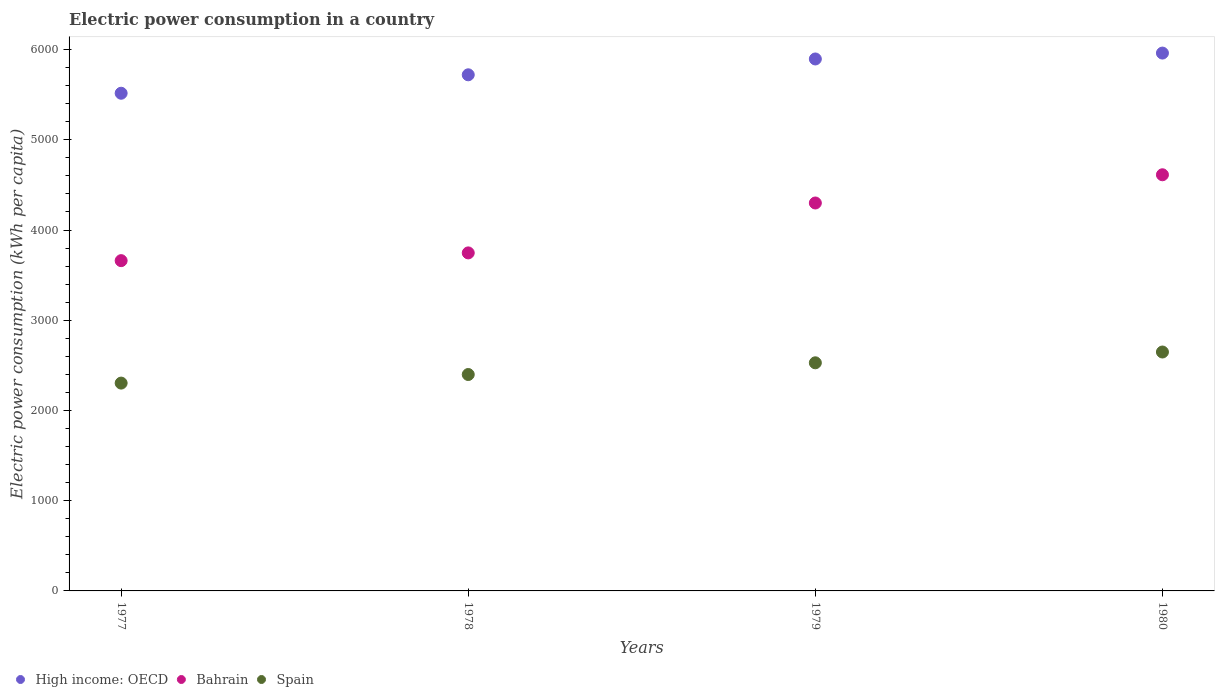Is the number of dotlines equal to the number of legend labels?
Offer a very short reply. Yes. What is the electric power consumption in in Spain in 1977?
Your answer should be very brief. 2303.41. Across all years, what is the maximum electric power consumption in in Spain?
Make the answer very short. 2647.9. Across all years, what is the minimum electric power consumption in in High income: OECD?
Provide a short and direct response. 5515.92. In which year was the electric power consumption in in Spain maximum?
Your answer should be compact. 1980. What is the total electric power consumption in in Spain in the graph?
Give a very brief answer. 9878.13. What is the difference between the electric power consumption in in High income: OECD in 1978 and that in 1980?
Offer a terse response. -240.79. What is the difference between the electric power consumption in in High income: OECD in 1978 and the electric power consumption in in Bahrain in 1977?
Keep it short and to the point. 2059.83. What is the average electric power consumption in in Spain per year?
Your answer should be very brief. 2469.53. In the year 1978, what is the difference between the electric power consumption in in High income: OECD and electric power consumption in in Spain?
Keep it short and to the point. 3321.81. In how many years, is the electric power consumption in in High income: OECD greater than 2400 kWh per capita?
Give a very brief answer. 4. What is the ratio of the electric power consumption in in High income: OECD in 1977 to that in 1979?
Your answer should be compact. 0.94. Is the electric power consumption in in Spain in 1977 less than that in 1978?
Offer a terse response. Yes. Is the difference between the electric power consumption in in High income: OECD in 1977 and 1980 greater than the difference between the electric power consumption in in Spain in 1977 and 1980?
Ensure brevity in your answer.  No. What is the difference between the highest and the second highest electric power consumption in in Bahrain?
Provide a short and direct response. 312.85. What is the difference between the highest and the lowest electric power consumption in in Spain?
Ensure brevity in your answer.  344.5. In how many years, is the electric power consumption in in Spain greater than the average electric power consumption in in Spain taken over all years?
Offer a terse response. 2. Does the electric power consumption in in Bahrain monotonically increase over the years?
Offer a terse response. Yes. How many dotlines are there?
Your answer should be very brief. 3. Are the values on the major ticks of Y-axis written in scientific E-notation?
Provide a succinct answer. No. Does the graph contain any zero values?
Ensure brevity in your answer.  No. Where does the legend appear in the graph?
Provide a succinct answer. Bottom left. How many legend labels are there?
Offer a terse response. 3. How are the legend labels stacked?
Keep it short and to the point. Horizontal. What is the title of the graph?
Provide a succinct answer. Electric power consumption in a country. Does "Equatorial Guinea" appear as one of the legend labels in the graph?
Make the answer very short. No. What is the label or title of the X-axis?
Make the answer very short. Years. What is the label or title of the Y-axis?
Your answer should be very brief. Electric power consumption (kWh per capita). What is the Electric power consumption (kWh per capita) of High income: OECD in 1977?
Give a very brief answer. 5515.92. What is the Electric power consumption (kWh per capita) of Bahrain in 1977?
Make the answer very short. 3660.52. What is the Electric power consumption (kWh per capita) of Spain in 1977?
Give a very brief answer. 2303.41. What is the Electric power consumption (kWh per capita) of High income: OECD in 1978?
Ensure brevity in your answer.  5720.35. What is the Electric power consumption (kWh per capita) of Bahrain in 1978?
Your answer should be very brief. 3746.4. What is the Electric power consumption (kWh per capita) in Spain in 1978?
Give a very brief answer. 2398.54. What is the Electric power consumption (kWh per capita) in High income: OECD in 1979?
Make the answer very short. 5895.81. What is the Electric power consumption (kWh per capita) in Bahrain in 1979?
Make the answer very short. 4299.52. What is the Electric power consumption (kWh per capita) of Spain in 1979?
Offer a terse response. 2528.28. What is the Electric power consumption (kWh per capita) in High income: OECD in 1980?
Make the answer very short. 5961.14. What is the Electric power consumption (kWh per capita) in Bahrain in 1980?
Offer a very short reply. 4612.37. What is the Electric power consumption (kWh per capita) in Spain in 1980?
Provide a succinct answer. 2647.9. Across all years, what is the maximum Electric power consumption (kWh per capita) of High income: OECD?
Provide a short and direct response. 5961.14. Across all years, what is the maximum Electric power consumption (kWh per capita) in Bahrain?
Keep it short and to the point. 4612.37. Across all years, what is the maximum Electric power consumption (kWh per capita) of Spain?
Make the answer very short. 2647.9. Across all years, what is the minimum Electric power consumption (kWh per capita) in High income: OECD?
Ensure brevity in your answer.  5515.92. Across all years, what is the minimum Electric power consumption (kWh per capita) in Bahrain?
Ensure brevity in your answer.  3660.52. Across all years, what is the minimum Electric power consumption (kWh per capita) in Spain?
Make the answer very short. 2303.41. What is the total Electric power consumption (kWh per capita) of High income: OECD in the graph?
Provide a short and direct response. 2.31e+04. What is the total Electric power consumption (kWh per capita) of Bahrain in the graph?
Offer a very short reply. 1.63e+04. What is the total Electric power consumption (kWh per capita) in Spain in the graph?
Provide a succinct answer. 9878.13. What is the difference between the Electric power consumption (kWh per capita) of High income: OECD in 1977 and that in 1978?
Your answer should be very brief. -204.43. What is the difference between the Electric power consumption (kWh per capita) in Bahrain in 1977 and that in 1978?
Give a very brief answer. -85.88. What is the difference between the Electric power consumption (kWh per capita) of Spain in 1977 and that in 1978?
Offer a terse response. -95.13. What is the difference between the Electric power consumption (kWh per capita) of High income: OECD in 1977 and that in 1979?
Give a very brief answer. -379.89. What is the difference between the Electric power consumption (kWh per capita) in Bahrain in 1977 and that in 1979?
Provide a succinct answer. -639. What is the difference between the Electric power consumption (kWh per capita) of Spain in 1977 and that in 1979?
Offer a terse response. -224.88. What is the difference between the Electric power consumption (kWh per capita) of High income: OECD in 1977 and that in 1980?
Your response must be concise. -445.22. What is the difference between the Electric power consumption (kWh per capita) of Bahrain in 1977 and that in 1980?
Your answer should be very brief. -951.85. What is the difference between the Electric power consumption (kWh per capita) in Spain in 1977 and that in 1980?
Provide a succinct answer. -344.5. What is the difference between the Electric power consumption (kWh per capita) in High income: OECD in 1978 and that in 1979?
Your answer should be very brief. -175.47. What is the difference between the Electric power consumption (kWh per capita) in Bahrain in 1978 and that in 1979?
Your answer should be very brief. -553.12. What is the difference between the Electric power consumption (kWh per capita) of Spain in 1978 and that in 1979?
Provide a short and direct response. -129.75. What is the difference between the Electric power consumption (kWh per capita) in High income: OECD in 1978 and that in 1980?
Make the answer very short. -240.79. What is the difference between the Electric power consumption (kWh per capita) of Bahrain in 1978 and that in 1980?
Offer a terse response. -865.97. What is the difference between the Electric power consumption (kWh per capita) of Spain in 1978 and that in 1980?
Your answer should be compact. -249.37. What is the difference between the Electric power consumption (kWh per capita) in High income: OECD in 1979 and that in 1980?
Give a very brief answer. -65.33. What is the difference between the Electric power consumption (kWh per capita) of Bahrain in 1979 and that in 1980?
Your answer should be compact. -312.85. What is the difference between the Electric power consumption (kWh per capita) in Spain in 1979 and that in 1980?
Give a very brief answer. -119.62. What is the difference between the Electric power consumption (kWh per capita) in High income: OECD in 1977 and the Electric power consumption (kWh per capita) in Bahrain in 1978?
Make the answer very short. 1769.53. What is the difference between the Electric power consumption (kWh per capita) of High income: OECD in 1977 and the Electric power consumption (kWh per capita) of Spain in 1978?
Ensure brevity in your answer.  3117.39. What is the difference between the Electric power consumption (kWh per capita) in Bahrain in 1977 and the Electric power consumption (kWh per capita) in Spain in 1978?
Your answer should be compact. 1261.98. What is the difference between the Electric power consumption (kWh per capita) in High income: OECD in 1977 and the Electric power consumption (kWh per capita) in Bahrain in 1979?
Your answer should be compact. 1216.4. What is the difference between the Electric power consumption (kWh per capita) of High income: OECD in 1977 and the Electric power consumption (kWh per capita) of Spain in 1979?
Offer a very short reply. 2987.64. What is the difference between the Electric power consumption (kWh per capita) in Bahrain in 1977 and the Electric power consumption (kWh per capita) in Spain in 1979?
Provide a succinct answer. 1132.23. What is the difference between the Electric power consumption (kWh per capita) in High income: OECD in 1977 and the Electric power consumption (kWh per capita) in Bahrain in 1980?
Offer a terse response. 903.55. What is the difference between the Electric power consumption (kWh per capita) in High income: OECD in 1977 and the Electric power consumption (kWh per capita) in Spain in 1980?
Provide a succinct answer. 2868.02. What is the difference between the Electric power consumption (kWh per capita) in Bahrain in 1977 and the Electric power consumption (kWh per capita) in Spain in 1980?
Your answer should be very brief. 1012.61. What is the difference between the Electric power consumption (kWh per capita) in High income: OECD in 1978 and the Electric power consumption (kWh per capita) in Bahrain in 1979?
Ensure brevity in your answer.  1420.83. What is the difference between the Electric power consumption (kWh per capita) of High income: OECD in 1978 and the Electric power consumption (kWh per capita) of Spain in 1979?
Ensure brevity in your answer.  3192.06. What is the difference between the Electric power consumption (kWh per capita) in Bahrain in 1978 and the Electric power consumption (kWh per capita) in Spain in 1979?
Keep it short and to the point. 1218.11. What is the difference between the Electric power consumption (kWh per capita) of High income: OECD in 1978 and the Electric power consumption (kWh per capita) of Bahrain in 1980?
Your answer should be compact. 1107.98. What is the difference between the Electric power consumption (kWh per capita) in High income: OECD in 1978 and the Electric power consumption (kWh per capita) in Spain in 1980?
Ensure brevity in your answer.  3072.44. What is the difference between the Electric power consumption (kWh per capita) in Bahrain in 1978 and the Electric power consumption (kWh per capita) in Spain in 1980?
Make the answer very short. 1098.49. What is the difference between the Electric power consumption (kWh per capita) in High income: OECD in 1979 and the Electric power consumption (kWh per capita) in Bahrain in 1980?
Your answer should be very brief. 1283.44. What is the difference between the Electric power consumption (kWh per capita) of High income: OECD in 1979 and the Electric power consumption (kWh per capita) of Spain in 1980?
Make the answer very short. 3247.91. What is the difference between the Electric power consumption (kWh per capita) of Bahrain in 1979 and the Electric power consumption (kWh per capita) of Spain in 1980?
Your response must be concise. 1651.61. What is the average Electric power consumption (kWh per capita) in High income: OECD per year?
Make the answer very short. 5773.3. What is the average Electric power consumption (kWh per capita) of Bahrain per year?
Offer a very short reply. 4079.7. What is the average Electric power consumption (kWh per capita) in Spain per year?
Ensure brevity in your answer.  2469.53. In the year 1977, what is the difference between the Electric power consumption (kWh per capita) of High income: OECD and Electric power consumption (kWh per capita) of Bahrain?
Give a very brief answer. 1855.41. In the year 1977, what is the difference between the Electric power consumption (kWh per capita) of High income: OECD and Electric power consumption (kWh per capita) of Spain?
Your answer should be compact. 3212.51. In the year 1977, what is the difference between the Electric power consumption (kWh per capita) of Bahrain and Electric power consumption (kWh per capita) of Spain?
Offer a very short reply. 1357.11. In the year 1978, what is the difference between the Electric power consumption (kWh per capita) in High income: OECD and Electric power consumption (kWh per capita) in Bahrain?
Make the answer very short. 1973.95. In the year 1978, what is the difference between the Electric power consumption (kWh per capita) of High income: OECD and Electric power consumption (kWh per capita) of Spain?
Your answer should be very brief. 3321.81. In the year 1978, what is the difference between the Electric power consumption (kWh per capita) in Bahrain and Electric power consumption (kWh per capita) in Spain?
Offer a very short reply. 1347.86. In the year 1979, what is the difference between the Electric power consumption (kWh per capita) of High income: OECD and Electric power consumption (kWh per capita) of Bahrain?
Offer a terse response. 1596.29. In the year 1979, what is the difference between the Electric power consumption (kWh per capita) in High income: OECD and Electric power consumption (kWh per capita) in Spain?
Your answer should be very brief. 3367.53. In the year 1979, what is the difference between the Electric power consumption (kWh per capita) in Bahrain and Electric power consumption (kWh per capita) in Spain?
Your response must be concise. 1771.24. In the year 1980, what is the difference between the Electric power consumption (kWh per capita) in High income: OECD and Electric power consumption (kWh per capita) in Bahrain?
Provide a succinct answer. 1348.77. In the year 1980, what is the difference between the Electric power consumption (kWh per capita) of High income: OECD and Electric power consumption (kWh per capita) of Spain?
Your response must be concise. 3313.23. In the year 1980, what is the difference between the Electric power consumption (kWh per capita) in Bahrain and Electric power consumption (kWh per capita) in Spain?
Provide a short and direct response. 1964.46. What is the ratio of the Electric power consumption (kWh per capita) of High income: OECD in 1977 to that in 1978?
Keep it short and to the point. 0.96. What is the ratio of the Electric power consumption (kWh per capita) in Bahrain in 1977 to that in 1978?
Your answer should be very brief. 0.98. What is the ratio of the Electric power consumption (kWh per capita) of Spain in 1977 to that in 1978?
Provide a succinct answer. 0.96. What is the ratio of the Electric power consumption (kWh per capita) of High income: OECD in 1977 to that in 1979?
Provide a short and direct response. 0.94. What is the ratio of the Electric power consumption (kWh per capita) of Bahrain in 1977 to that in 1979?
Keep it short and to the point. 0.85. What is the ratio of the Electric power consumption (kWh per capita) in Spain in 1977 to that in 1979?
Provide a succinct answer. 0.91. What is the ratio of the Electric power consumption (kWh per capita) in High income: OECD in 1977 to that in 1980?
Your answer should be compact. 0.93. What is the ratio of the Electric power consumption (kWh per capita) of Bahrain in 1977 to that in 1980?
Keep it short and to the point. 0.79. What is the ratio of the Electric power consumption (kWh per capita) of Spain in 1977 to that in 1980?
Your answer should be compact. 0.87. What is the ratio of the Electric power consumption (kWh per capita) of High income: OECD in 1978 to that in 1979?
Offer a terse response. 0.97. What is the ratio of the Electric power consumption (kWh per capita) of Bahrain in 1978 to that in 1979?
Make the answer very short. 0.87. What is the ratio of the Electric power consumption (kWh per capita) of Spain in 1978 to that in 1979?
Offer a terse response. 0.95. What is the ratio of the Electric power consumption (kWh per capita) in High income: OECD in 1978 to that in 1980?
Provide a short and direct response. 0.96. What is the ratio of the Electric power consumption (kWh per capita) in Bahrain in 1978 to that in 1980?
Give a very brief answer. 0.81. What is the ratio of the Electric power consumption (kWh per capita) in Spain in 1978 to that in 1980?
Your answer should be very brief. 0.91. What is the ratio of the Electric power consumption (kWh per capita) in High income: OECD in 1979 to that in 1980?
Your response must be concise. 0.99. What is the ratio of the Electric power consumption (kWh per capita) in Bahrain in 1979 to that in 1980?
Provide a short and direct response. 0.93. What is the ratio of the Electric power consumption (kWh per capita) in Spain in 1979 to that in 1980?
Your answer should be very brief. 0.95. What is the difference between the highest and the second highest Electric power consumption (kWh per capita) in High income: OECD?
Your answer should be compact. 65.33. What is the difference between the highest and the second highest Electric power consumption (kWh per capita) in Bahrain?
Your answer should be compact. 312.85. What is the difference between the highest and the second highest Electric power consumption (kWh per capita) of Spain?
Give a very brief answer. 119.62. What is the difference between the highest and the lowest Electric power consumption (kWh per capita) of High income: OECD?
Give a very brief answer. 445.22. What is the difference between the highest and the lowest Electric power consumption (kWh per capita) of Bahrain?
Your response must be concise. 951.85. What is the difference between the highest and the lowest Electric power consumption (kWh per capita) of Spain?
Offer a very short reply. 344.5. 